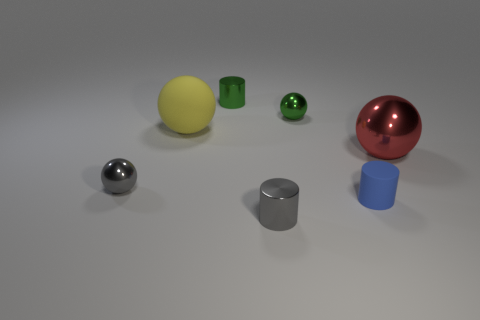Add 3 large rubber balls. How many objects exist? 10 Subtract all balls. How many objects are left? 3 Add 5 rubber spheres. How many rubber spheres are left? 6 Add 7 big shiny spheres. How many big shiny spheres exist? 8 Subtract 0 cyan spheres. How many objects are left? 7 Subtract all cyan rubber cylinders. Subtract all large yellow balls. How many objects are left? 6 